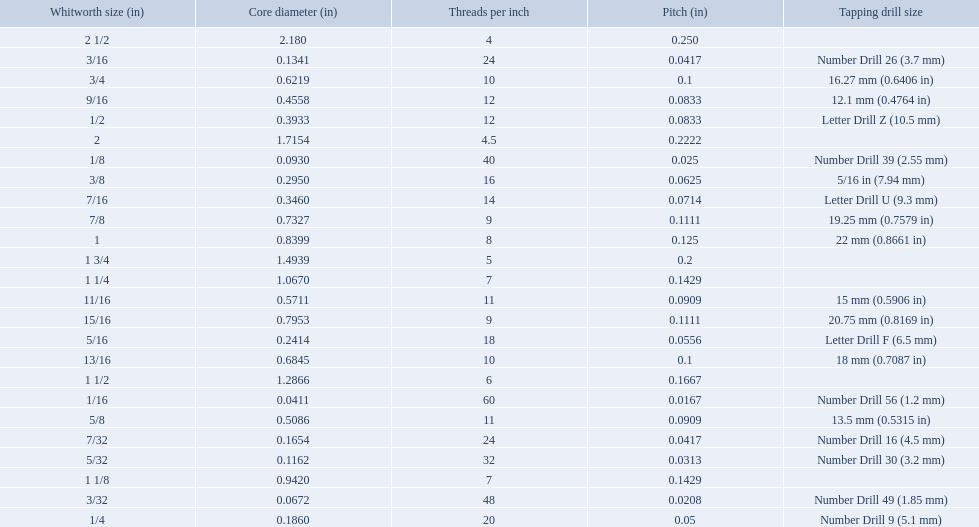What are the standard whitworth sizes in inches? 1/16, 3/32, 1/8, 5/32, 3/16, 7/32, 1/4, 5/16, 3/8, 7/16, 1/2, 9/16, 5/8, 11/16, 3/4, 13/16, 7/8, 15/16, 1, 1 1/8, 1 1/4, 1 1/2, 1 3/4, 2, 2 1/2. How many threads per inch does the 3/16 size have? 24. Which size (in inches) has the same number of threads? 7/32. What are the sizes of threads per inch? 60, 48, 40, 32, 24, 24, 20, 18, 16, 14, 12, 12, 11, 11, 10, 10, 9, 9, 8, 7, 7, 6, 5, 4.5, 4. Which whitworth size has only 5 threads per inch? 1 3/4. What was the core diameter of a number drill 26 0.1341. What is this measurement in whitworth size? 3/16. 